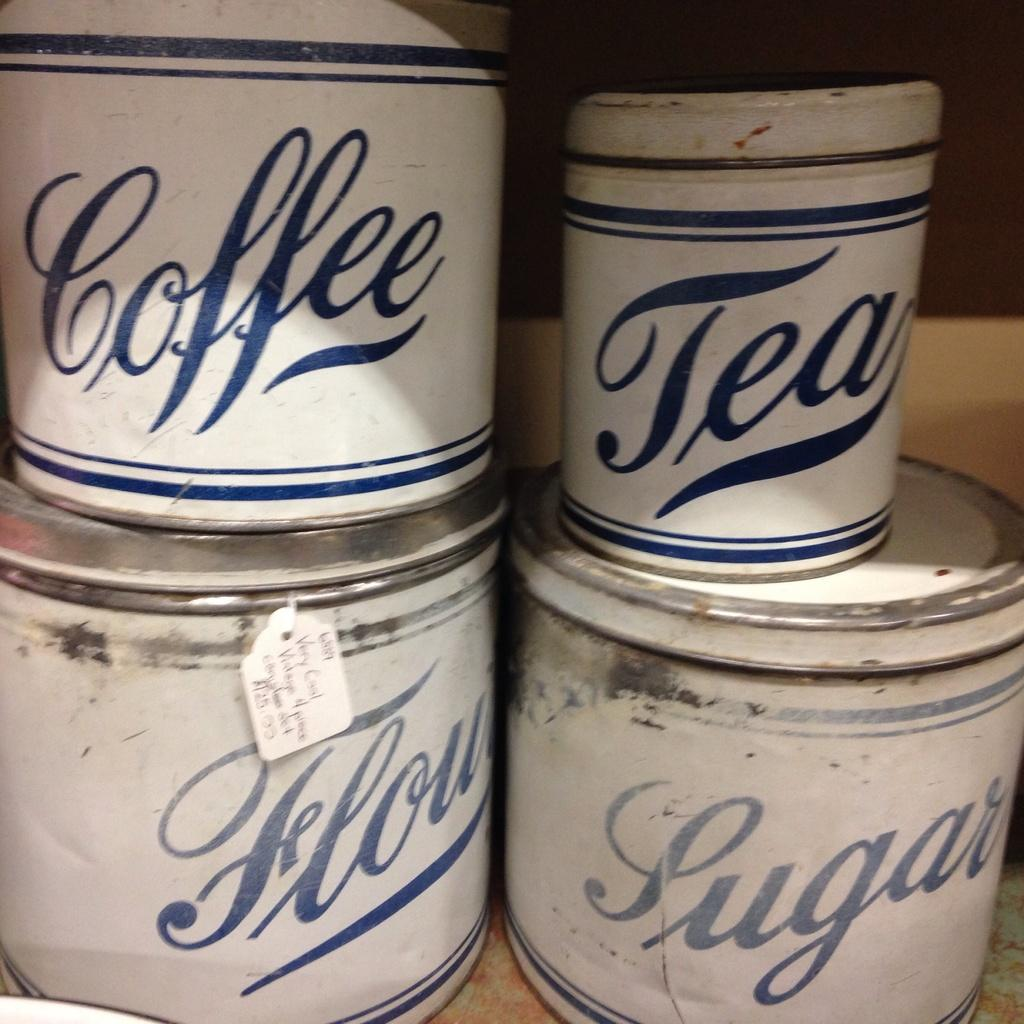Provide a one-sentence caption for the provided image. Several different cans stacked up that say things like Coffee and Tea. 